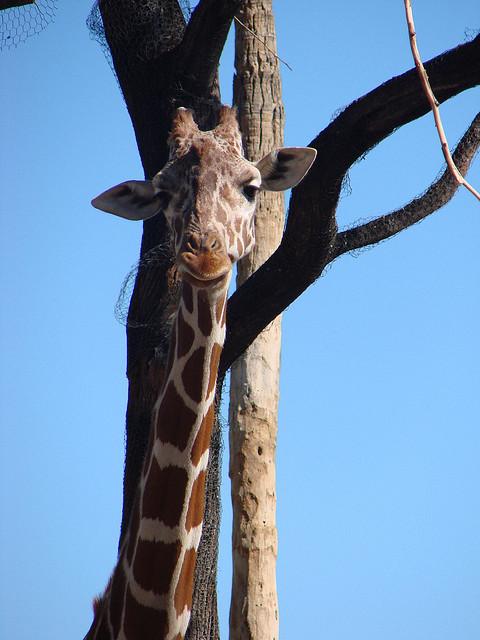Is the giraffe alone?
Keep it brief. Yes. Is the giraffe looking away?
Be succinct. No. Is the tree taller than the giraffe?
Write a very short answer. Yes. 